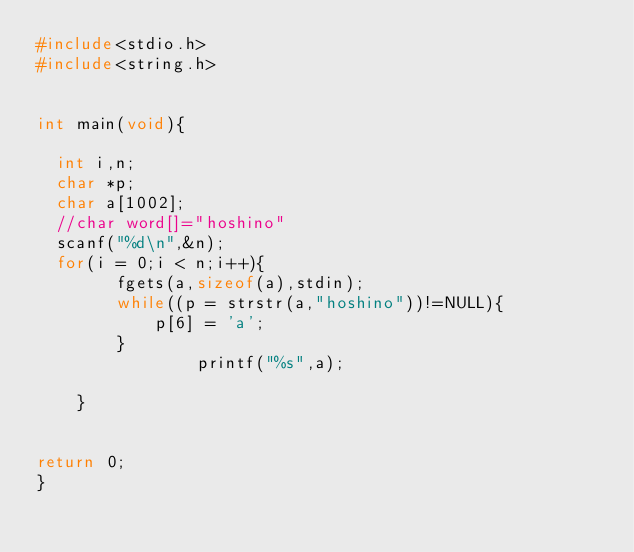Convert code to text. <code><loc_0><loc_0><loc_500><loc_500><_C_>#include<stdio.h>
#include<string.h>


int main(void){

	int i,n;
	char *p;
	char a[1002];
	//char word[]="hoshino"
	scanf("%d\n",&n);
	for(i = 0;i < n;i++){
        fgets(a,sizeof(a),stdin);
        while((p = strstr(a,"hoshino"))!=NULL){
            p[6] = 'a';
        }
                printf("%s",a);

    }


return 0;
}</code> 